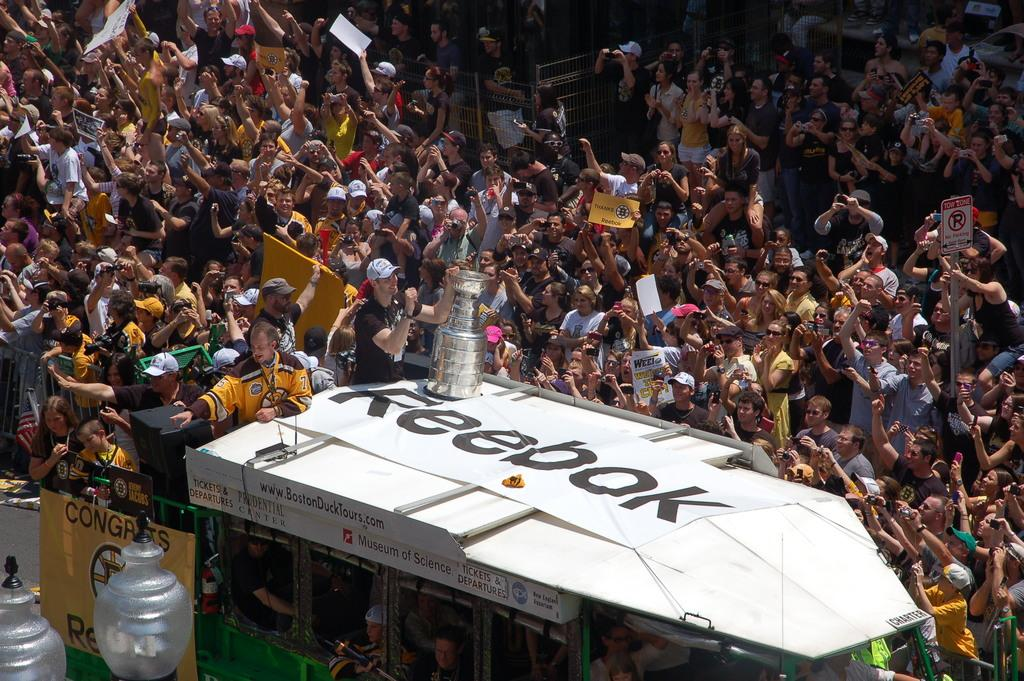What is the main subject of the image? The main subject of the image is a crowd of people. Can you describe the presence of a vehicle in the image? Yes, there are people on a van in the image. Where is the van located in the image? The van is visible at the bottom of the image. What else can be seen in the bottom left of the image? Lights are visible in the bottom left of the image. What emotion do the people in the crowd regret feeling in the image? There is no indication of any emotions or regrets in the image; it simply shows a crowd of people and a van. 